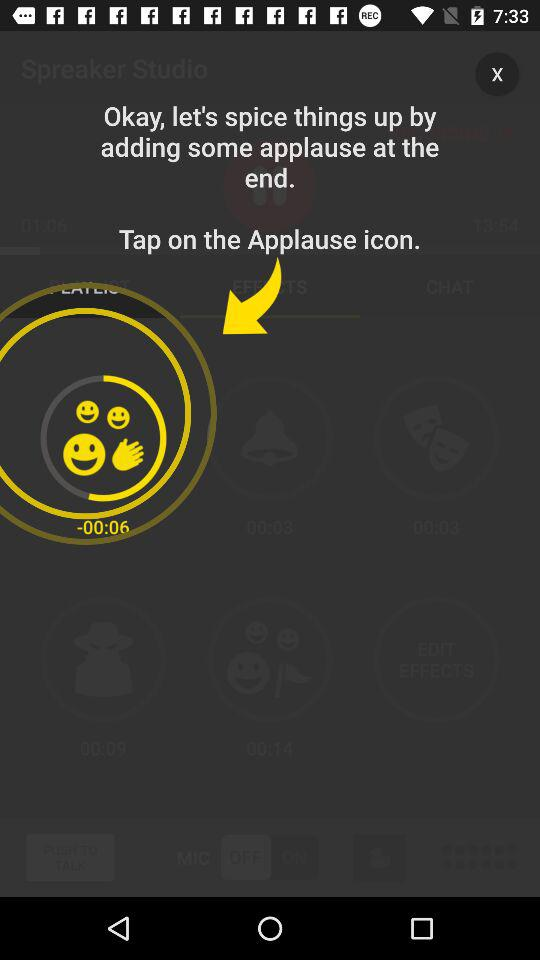Which tab am I on? You are on the "EFFECTS" tab. 